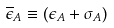Convert formula to latex. <formula><loc_0><loc_0><loc_500><loc_500>\overline { \epsilon } _ { A } \equiv ( \epsilon _ { A } + \sigma _ { A } )</formula> 